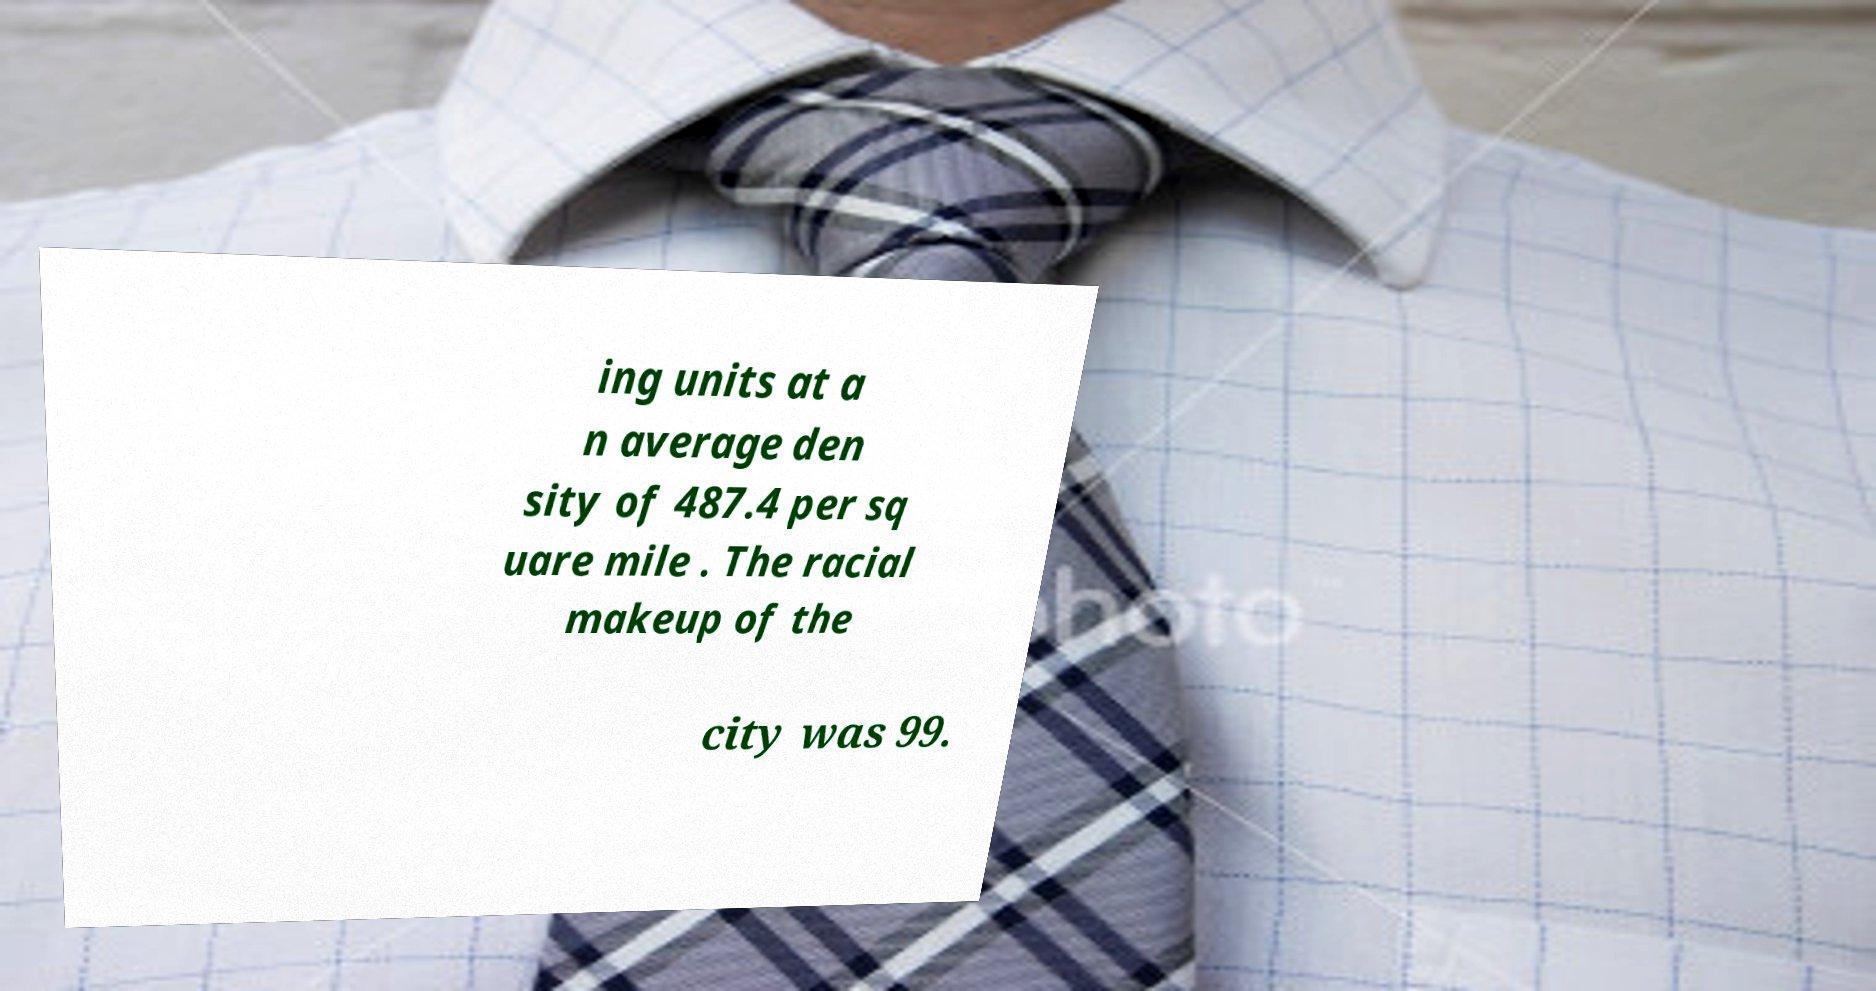Can you read and provide the text displayed in the image?This photo seems to have some interesting text. Can you extract and type it out for me? ing units at a n average den sity of 487.4 per sq uare mile . The racial makeup of the city was 99. 